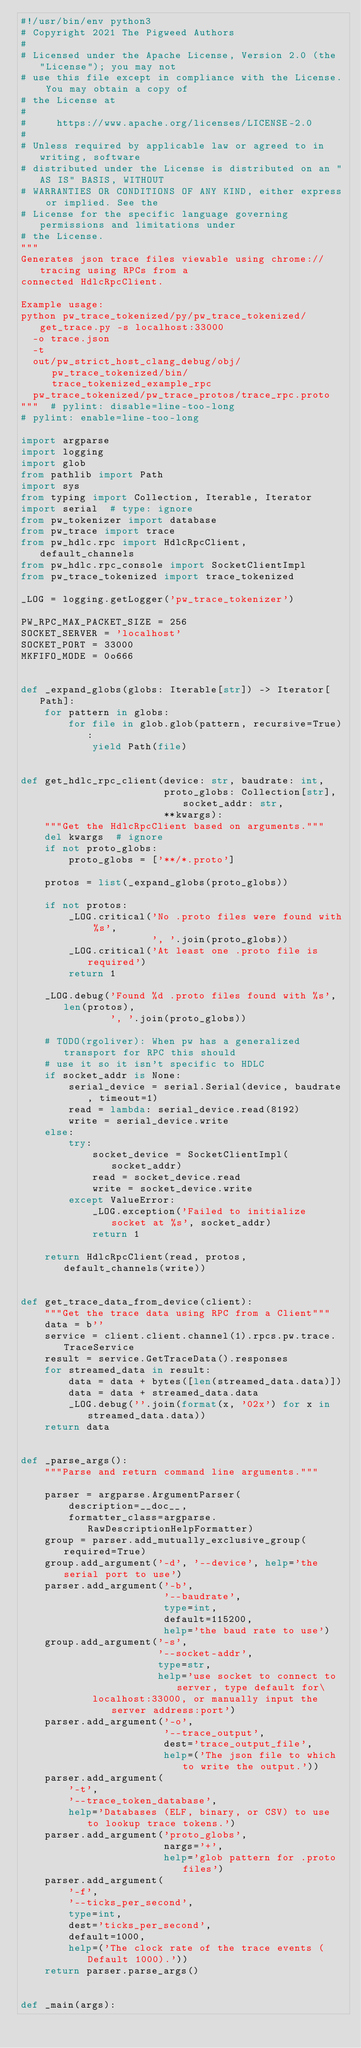<code> <loc_0><loc_0><loc_500><loc_500><_Python_>#!/usr/bin/env python3
# Copyright 2021 The Pigweed Authors
#
# Licensed under the Apache License, Version 2.0 (the "License"); you may not
# use this file except in compliance with the License. You may obtain a copy of
# the License at
#
#     https://www.apache.org/licenses/LICENSE-2.0
#
# Unless required by applicable law or agreed to in writing, software
# distributed under the License is distributed on an "AS IS" BASIS, WITHOUT
# WARRANTIES OR CONDITIONS OF ANY KIND, either express or implied. See the
# License for the specific language governing permissions and limitations under
# the License.
"""
Generates json trace files viewable using chrome://tracing using RPCs from a
connected HdlcRpcClient.

Example usage:
python pw_trace_tokenized/py/pw_trace_tokenized/get_trace.py -s localhost:33000
  -o trace.json
  -t
  out/pw_strict_host_clang_debug/obj/pw_trace_tokenized/bin/trace_tokenized_example_rpc
  pw_trace_tokenized/pw_trace_protos/trace_rpc.proto
"""  # pylint: disable=line-too-long
# pylint: enable=line-too-long

import argparse
import logging
import glob
from pathlib import Path
import sys
from typing import Collection, Iterable, Iterator
import serial  # type: ignore
from pw_tokenizer import database
from pw_trace import trace
from pw_hdlc.rpc import HdlcRpcClient, default_channels
from pw_hdlc.rpc_console import SocketClientImpl
from pw_trace_tokenized import trace_tokenized

_LOG = logging.getLogger('pw_trace_tokenizer')

PW_RPC_MAX_PACKET_SIZE = 256
SOCKET_SERVER = 'localhost'
SOCKET_PORT = 33000
MKFIFO_MODE = 0o666


def _expand_globs(globs: Iterable[str]) -> Iterator[Path]:
    for pattern in globs:
        for file in glob.glob(pattern, recursive=True):
            yield Path(file)


def get_hdlc_rpc_client(device: str, baudrate: int,
                        proto_globs: Collection[str], socket_addr: str,
                        **kwargs):
    """Get the HdlcRpcClient based on arguments."""
    del kwargs  # ignore
    if not proto_globs:
        proto_globs = ['**/*.proto']

    protos = list(_expand_globs(proto_globs))

    if not protos:
        _LOG.critical('No .proto files were found with %s',
                      ', '.join(proto_globs))
        _LOG.critical('At least one .proto file is required')
        return 1

    _LOG.debug('Found %d .proto files found with %s', len(protos),
               ', '.join(proto_globs))

    # TODO(rgoliver): When pw has a generalized transport for RPC this should
    # use it so it isn't specific to HDLC
    if socket_addr is None:
        serial_device = serial.Serial(device, baudrate, timeout=1)
        read = lambda: serial_device.read(8192)
        write = serial_device.write
    else:
        try:
            socket_device = SocketClientImpl(socket_addr)
            read = socket_device.read
            write = socket_device.write
        except ValueError:
            _LOG.exception('Failed to initialize socket at %s', socket_addr)
            return 1

    return HdlcRpcClient(read, protos, default_channels(write))


def get_trace_data_from_device(client):
    """Get the trace data using RPC from a Client"""
    data = b''
    service = client.client.channel(1).rpcs.pw.trace.TraceService
    result = service.GetTraceData().responses
    for streamed_data in result:
        data = data + bytes([len(streamed_data.data)])
        data = data + streamed_data.data
        _LOG.debug(''.join(format(x, '02x') for x in streamed_data.data))
    return data


def _parse_args():
    """Parse and return command line arguments."""

    parser = argparse.ArgumentParser(
        description=__doc__,
        formatter_class=argparse.RawDescriptionHelpFormatter)
    group = parser.add_mutually_exclusive_group(required=True)
    group.add_argument('-d', '--device', help='the serial port to use')
    parser.add_argument('-b',
                        '--baudrate',
                        type=int,
                        default=115200,
                        help='the baud rate to use')
    group.add_argument('-s',
                       '--socket-addr',
                       type=str,
                       help='use socket to connect to server, type default for\
            localhost:33000, or manually input the server address:port')
    parser.add_argument('-o',
                        '--trace_output',
                        dest='trace_output_file',
                        help=('The json file to which to write the output.'))
    parser.add_argument(
        '-t',
        '--trace_token_database',
        help='Databases (ELF, binary, or CSV) to use to lookup trace tokens.')
    parser.add_argument('proto_globs',
                        nargs='+',
                        help='glob pattern for .proto files')
    parser.add_argument(
        '-f',
        '--ticks_per_second',
        type=int,
        dest='ticks_per_second',
        default=1000,
        help=('The clock rate of the trace events (Default 1000).'))
    return parser.parse_args()


def _main(args):</code> 